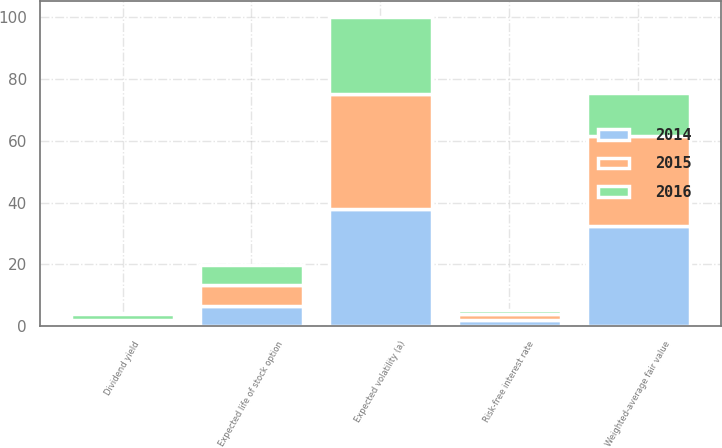Convert chart. <chart><loc_0><loc_0><loc_500><loc_500><stacked_bar_chart><ecel><fcel>Dividend yield<fcel>Expected volatility (a)<fcel>Risk-free interest rate<fcel>Expected life of stock option<fcel>Weighted-average fair value<nl><fcel>2016<fcel>1.9<fcel>25<fcel>1.5<fcel>6.3<fcel>13.67<nl><fcel>2015<fcel>1.1<fcel>37<fcel>1.7<fcel>6.7<fcel>29.2<nl><fcel>2014<fcel>1.1<fcel>38<fcel>2.2<fcel>6.7<fcel>32.36<nl></chart> 